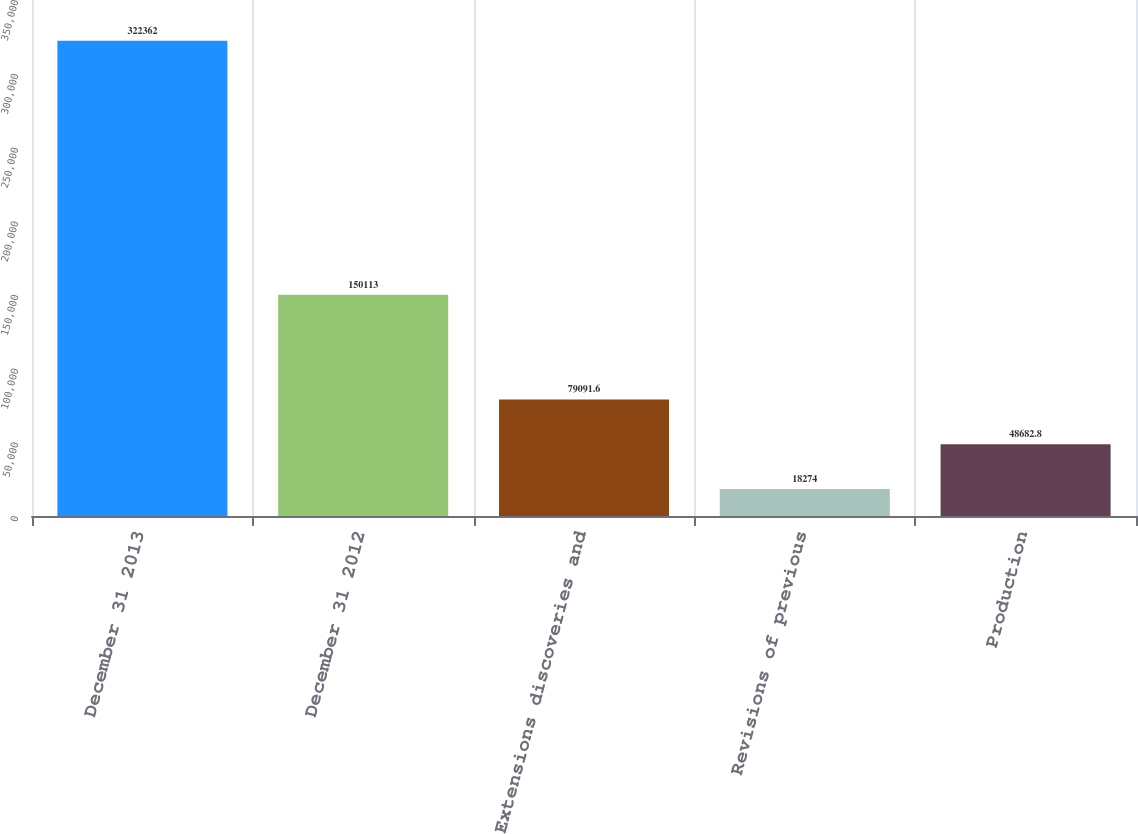Convert chart to OTSL. <chart><loc_0><loc_0><loc_500><loc_500><bar_chart><fcel>December 31 2013<fcel>December 31 2012<fcel>Extensions discoveries and<fcel>Revisions of previous<fcel>Production<nl><fcel>322362<fcel>150113<fcel>79091.6<fcel>18274<fcel>48682.8<nl></chart> 